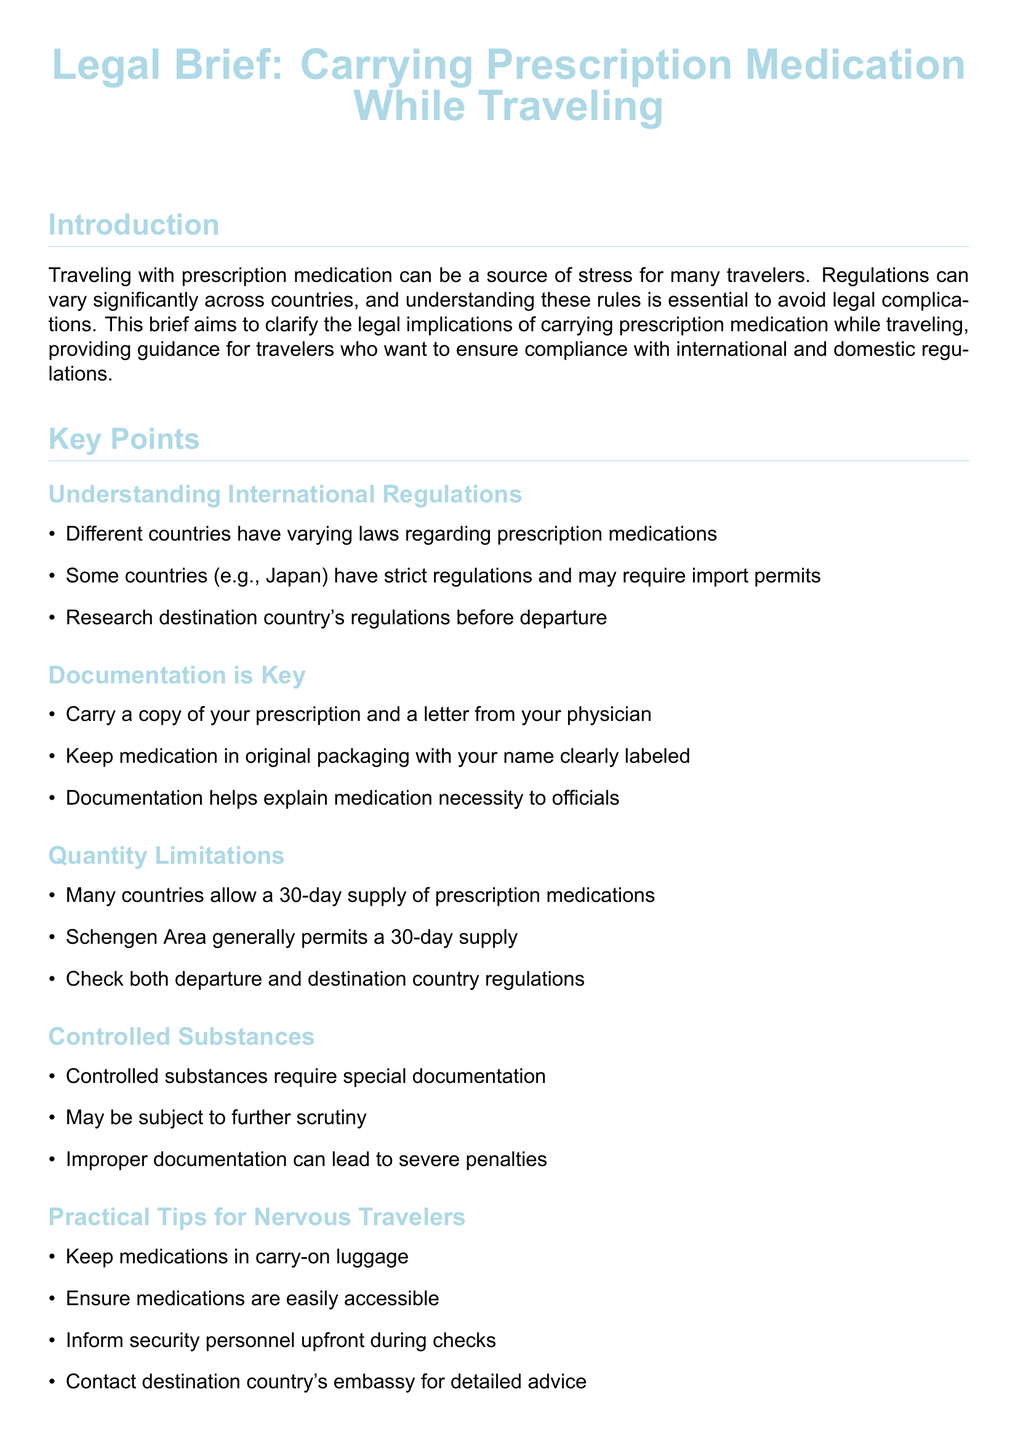What is the title of the document? The title of the document is presented at the beginning of the legal brief.
Answer: Legal Brief: Carrying Prescription Medication While Traveling What should you carry for your medication? The document specifies essential items to carry when traveling with prescription medication.
Answer: A copy of your prescription and a letter from your physician What is a recommended quantity of prescription medication for travel in the Schengen Area? The document mentions how much medication is generally allowed for travelers in the Schengen Area.
Answer: A 30-day supply What could result from improper documentation of controlled substances? The document highlights the consequences of not having proper documents for specific medications.
Answer: Severe penalties Which countries have strict regulations about prescription medications? The key points mention specific countries as examples of those with strict laws regarding medications.
Answer: Japan What should you do if you're unsure about regulations? The conclusion provides a suggestion for travelers who want more information on legal requirements.
Answer: Consult relevant authorities Where should medications be kept during travel? The practical tips section advises where to store medications while traveling.
Answer: Carry-on luggage What type of substances require special documentation? The document specifies a category of medications that needs extra attention and paperwork.
Answer: Controlled substances 